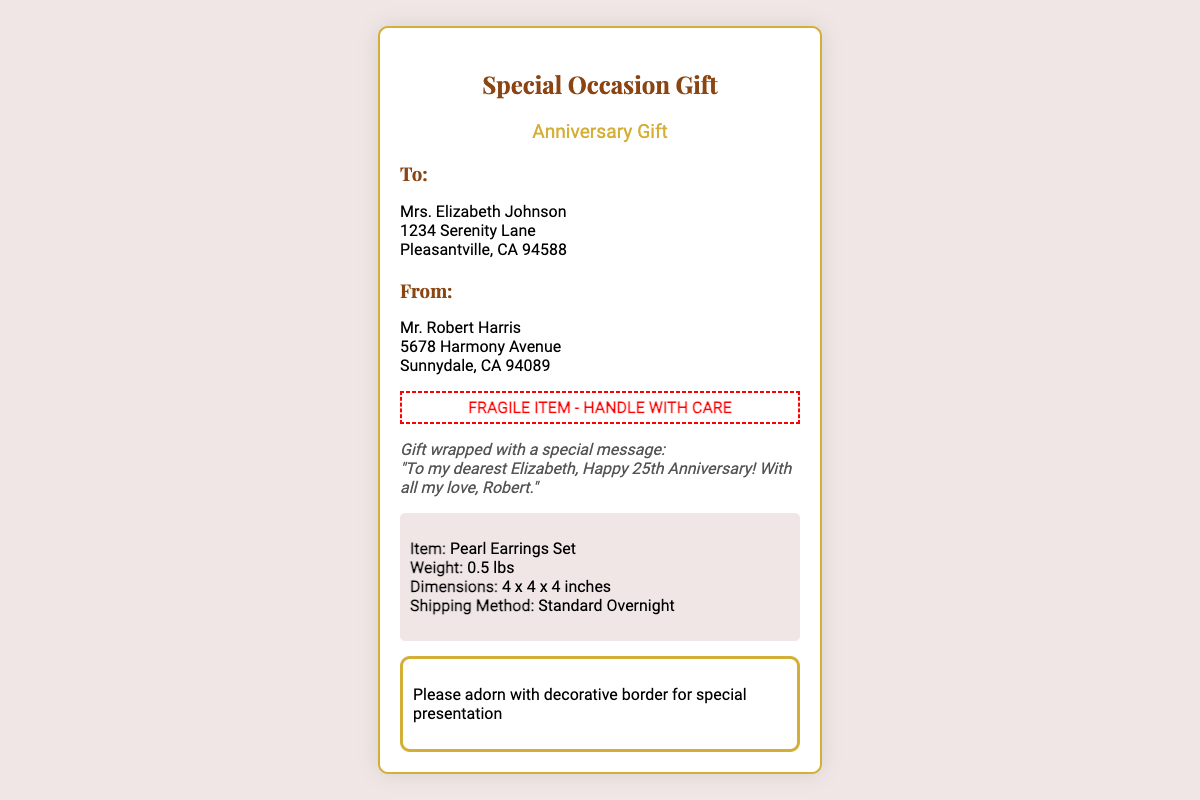What is the occasion for the gift? The occasion is mentioned in the document as "Anniversary Gift."
Answer: Anniversary Gift Who is the recipient of the gift? The "To" section lists Mrs. Elizabeth Johnson as the recipient.
Answer: Mrs. Elizabeth Johnson What type of item is being shipped? The package information states that the item is a "Pearl Earrings Set."
Answer: Pearl Earrings Set Who is sending the gift? The "From" section indicates that Mr. Robert Harris is the sender.
Answer: Mr. Robert Harris What is the weight of the item? The package info specifies the weight of the item as "0.5 lbs."
Answer: 0.5 lbs What is the shipping method used? The document details the shipping method as "Standard Overnight."
Answer: Standard Overnight What special message is included with the gift? The instructions section includes a message addressed to Elizabeth, highlighting the sentiment.
Answer: "To my dearest Elizabeth, Happy 25th Anniversary! With all my love, Robert." What is indicated on the label regarding the handling of the item? The label has a warning indicating that it is a fragile item.
Answer: FRAGILE ITEM - HANDLE WITH CARE What additional decoration is requested for the presentation? The last section requests that the package be adorned with a "decorative border."
Answer: decorative border 